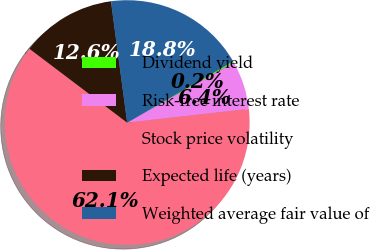Convert chart to OTSL. <chart><loc_0><loc_0><loc_500><loc_500><pie_chart><fcel>Dividend yield<fcel>Risk-free interest rate<fcel>Stock price volatility<fcel>Expected life (years)<fcel>Weighted average fair value of<nl><fcel>0.19%<fcel>6.38%<fcel>62.09%<fcel>12.58%<fcel>18.77%<nl></chart> 